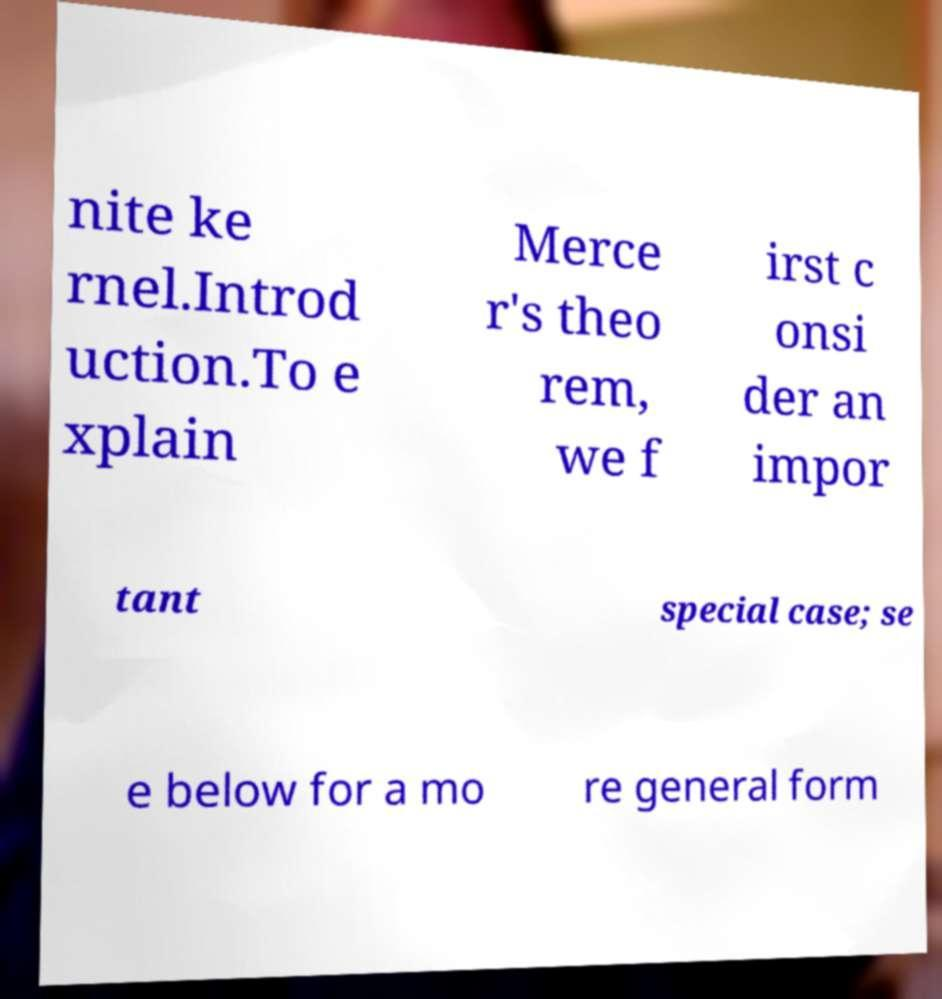What messages or text are displayed in this image? I need them in a readable, typed format. nite ke rnel.Introd uction.To e xplain Merce r's theo rem, we f irst c onsi der an impor tant special case; se e below for a mo re general form 